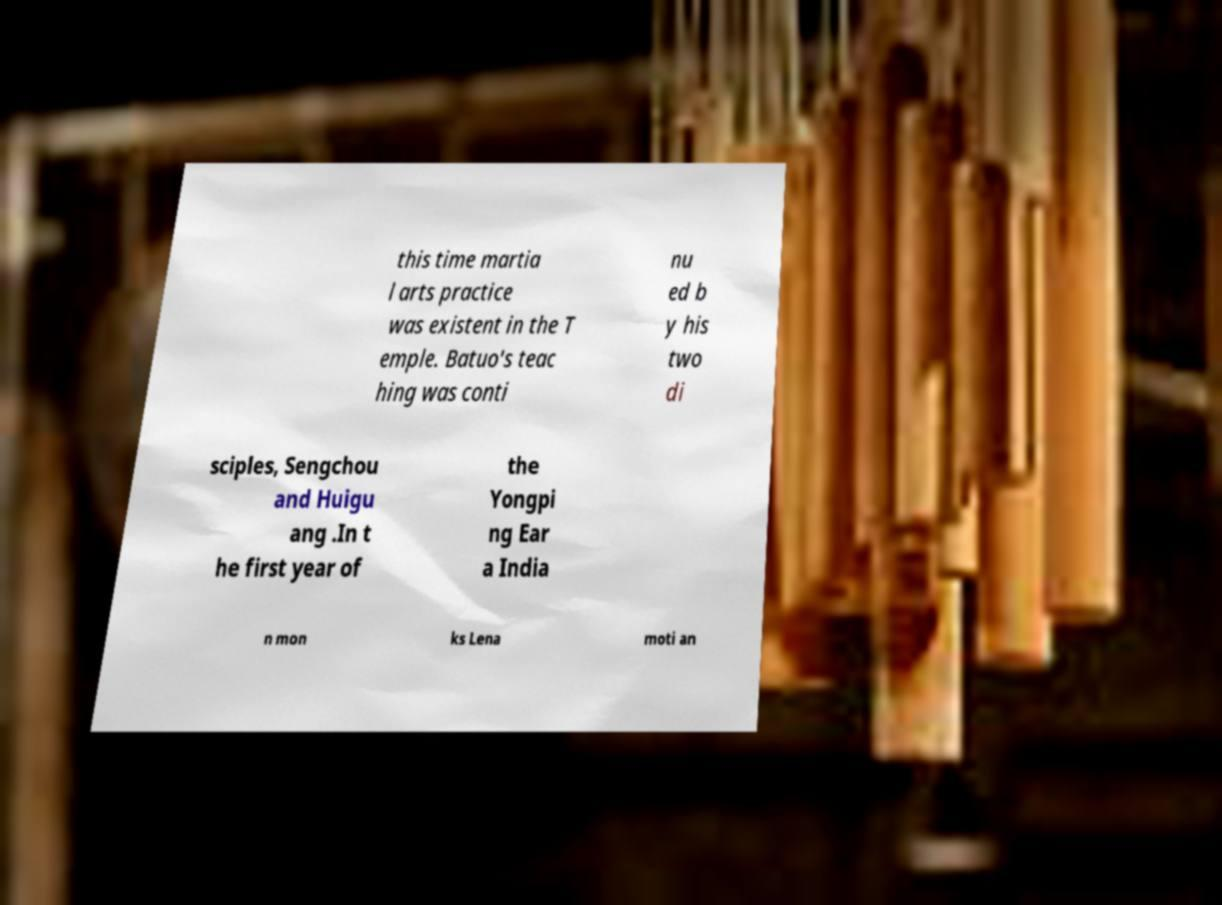Please read and relay the text visible in this image. What does it say? this time martia l arts practice was existent in the T emple. Batuo's teac hing was conti nu ed b y his two di sciples, Sengchou and Huigu ang .In t he first year of the Yongpi ng Ear a India n mon ks Lena moti an 